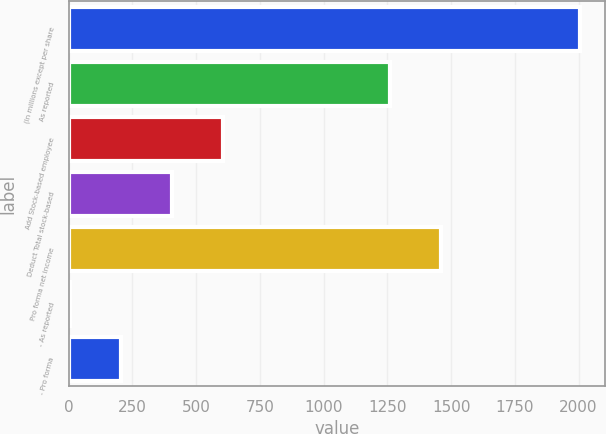Convert chart to OTSL. <chart><loc_0><loc_0><loc_500><loc_500><bar_chart><fcel>(In millions except per share<fcel>As reported<fcel>Add Stock-based employee<fcel>Deduct Total stock-based<fcel>Pro forma net income<fcel>- As reported<fcel>- Pro forma<nl><fcel>2004<fcel>1261<fcel>603.84<fcel>403.81<fcel>1461.03<fcel>3.75<fcel>203.78<nl></chart> 